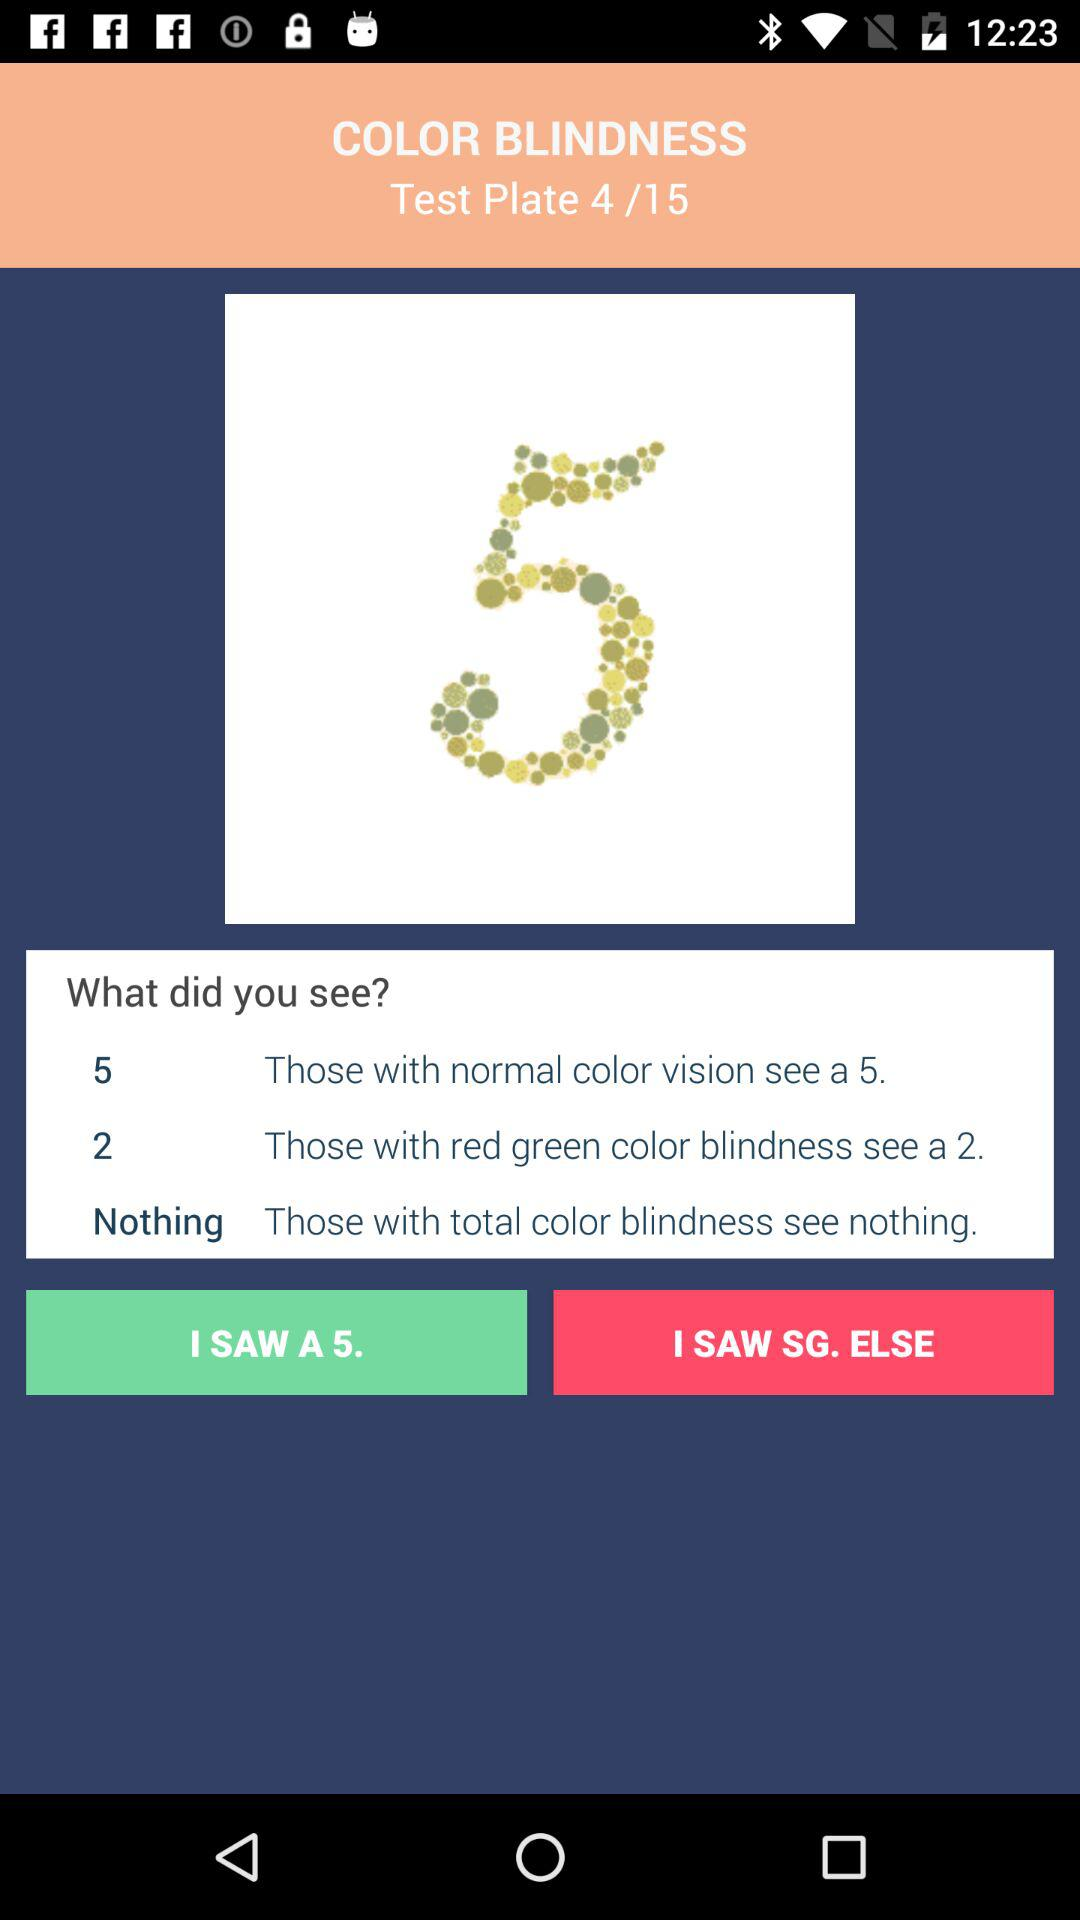How many test plates in total are there? There are 15 test plates in total. 